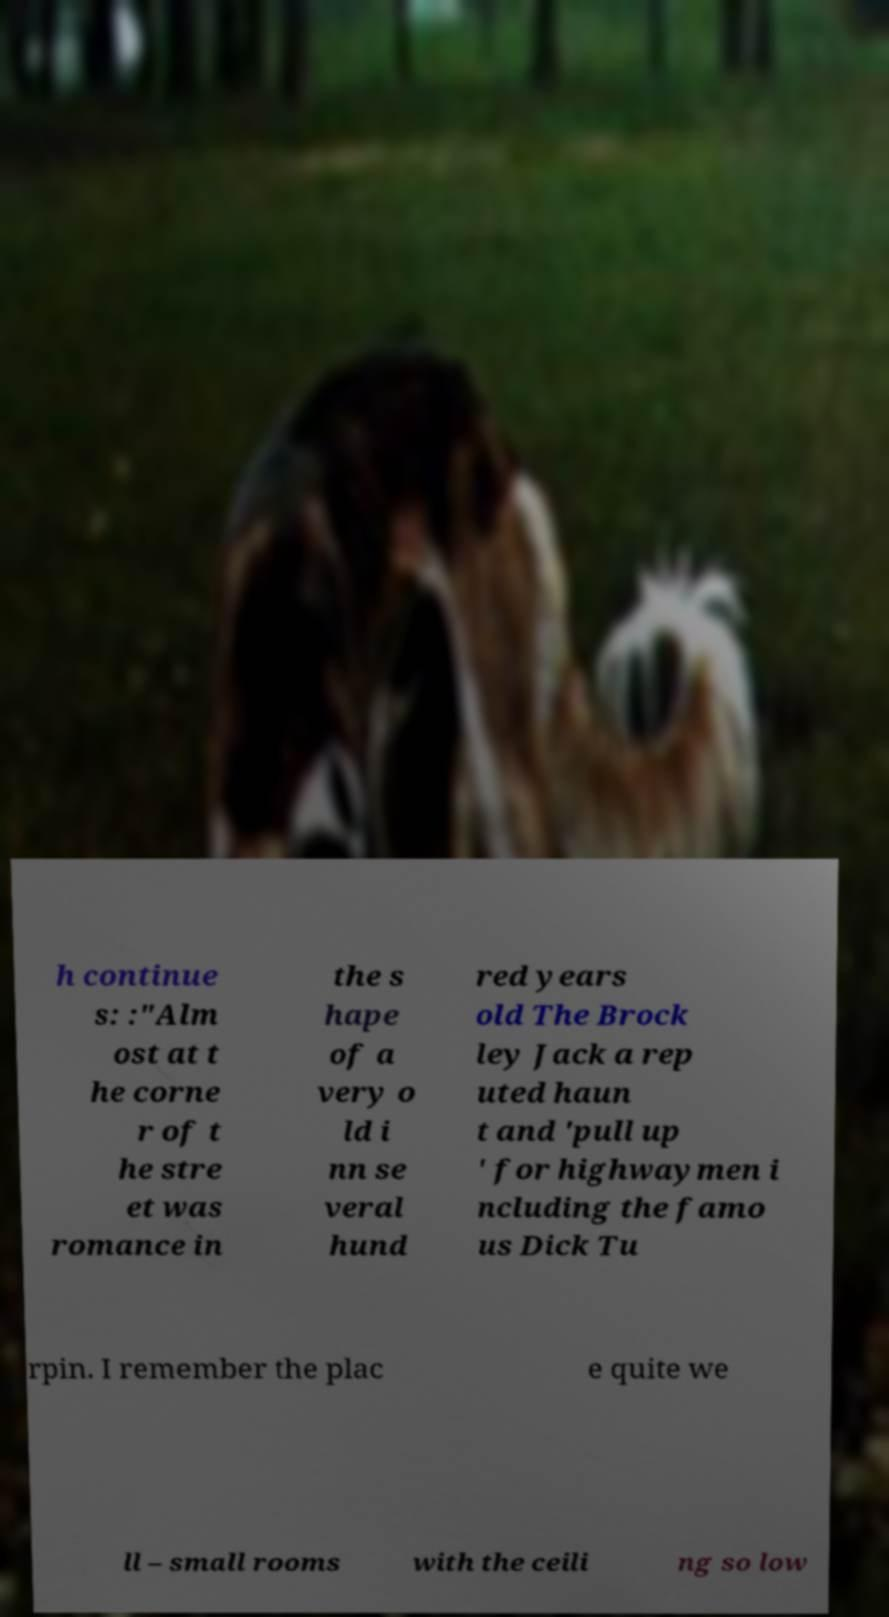Can you read and provide the text displayed in the image?This photo seems to have some interesting text. Can you extract and type it out for me? h continue s: :"Alm ost at t he corne r of t he stre et was romance in the s hape of a very o ld i nn se veral hund red years old The Brock ley Jack a rep uted haun t and 'pull up ' for highwaymen i ncluding the famo us Dick Tu rpin. I remember the plac e quite we ll – small rooms with the ceili ng so low 